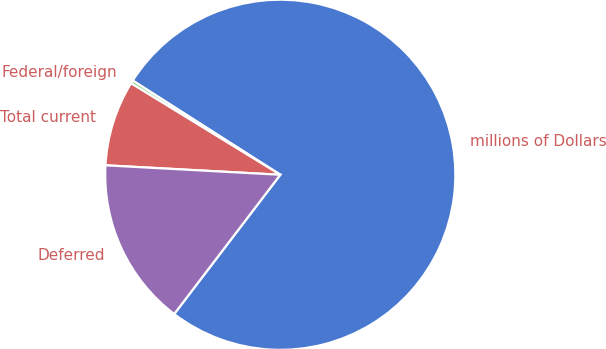Convert chart to OTSL. <chart><loc_0><loc_0><loc_500><loc_500><pie_chart><fcel>millions of Dollars<fcel>Federal/foreign<fcel>Total current<fcel>Deferred<nl><fcel>76.32%<fcel>0.29%<fcel>7.89%<fcel>15.5%<nl></chart> 